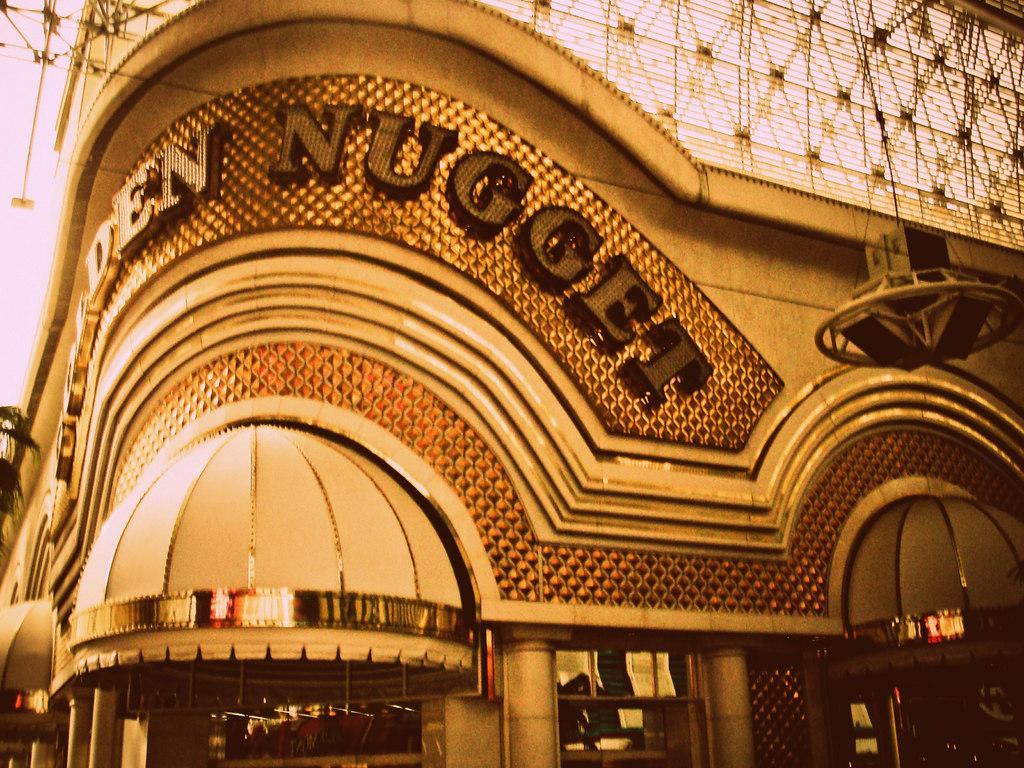Describe this image in one or two sentences. In the center of the image there is a building. At the top there are wires. 